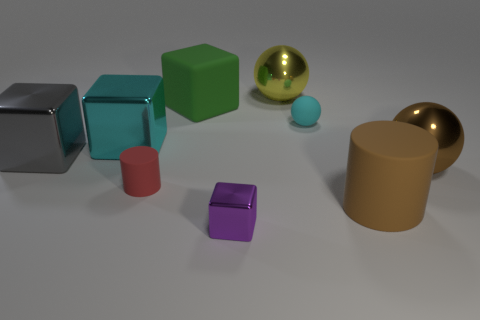Subtract all cylinders. How many objects are left? 7 Add 3 large metallic spheres. How many large metallic spheres are left? 5 Add 1 small rubber objects. How many small rubber objects exist? 3 Subtract 0 gray spheres. How many objects are left? 9 Subtract all small blue cylinders. Subtract all big things. How many objects are left? 3 